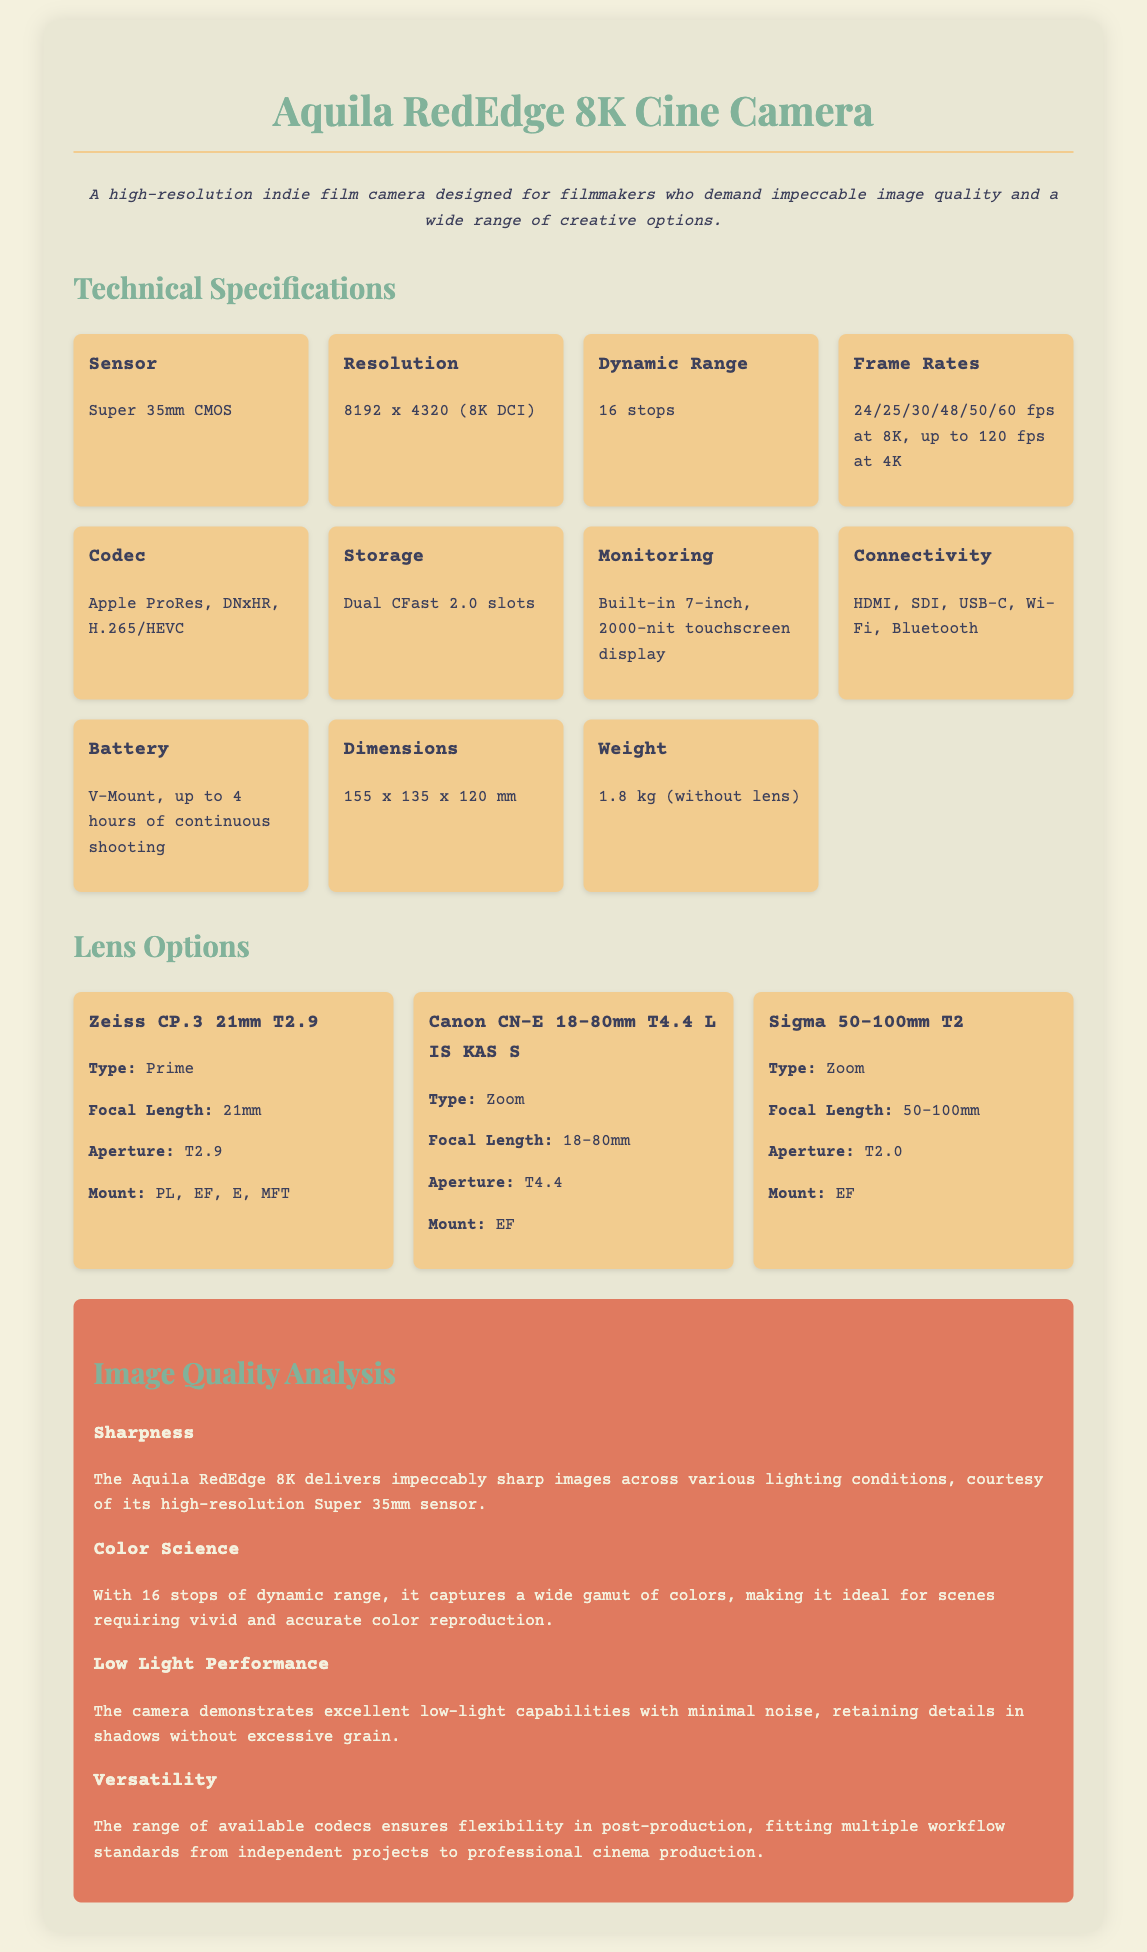What type of sensor does the camera use? The sensor type is specifically mentioned under the Technical Specifications section of the document.
Answer: Super 35mm CMOS What is the resolution of the Aquila RedEdge camera? The resolution is stated clearly in the Technical Specifications section.
Answer: 8192 x 4320 (8K DCI) How many stops of dynamic range does the camera have? The dynamic range is listed in the Technical Specifications section, providing a specific value.
Answer: 16 stops What is the maximum frame rate at 4K? The maximum frame rate for 4K is mentioned in the context of frame rate capabilities in the document.
Answer: 120 fps What is the weight of the camera without the lens? The weight is detailed in the Technical Specifications section, providing a specific measurement.
Answer: 1.8 kg (without lens) What type of lens is the Canon CN-E 18-80mm? The lens type is indicated in the Lens Options section of the document, showing its category.
Answer: Zoom What is the aperture of the Sigma 50-100mm lens? The aperture information for this lens is provided in the Lens Options section, detailing its specifications.
Answer: T2.0 How does the camera perform in low light? The low light performance is summarized in the Image Quality Analysis, discussing its capabilities.
Answer: Excellent What are the available connectivity options for the camera? Connectivity options are listed in the Technical Specifications section, providing a range of formats.
Answer: HDMI, SDI, USB-C, Wi-Fi, Bluetooth 